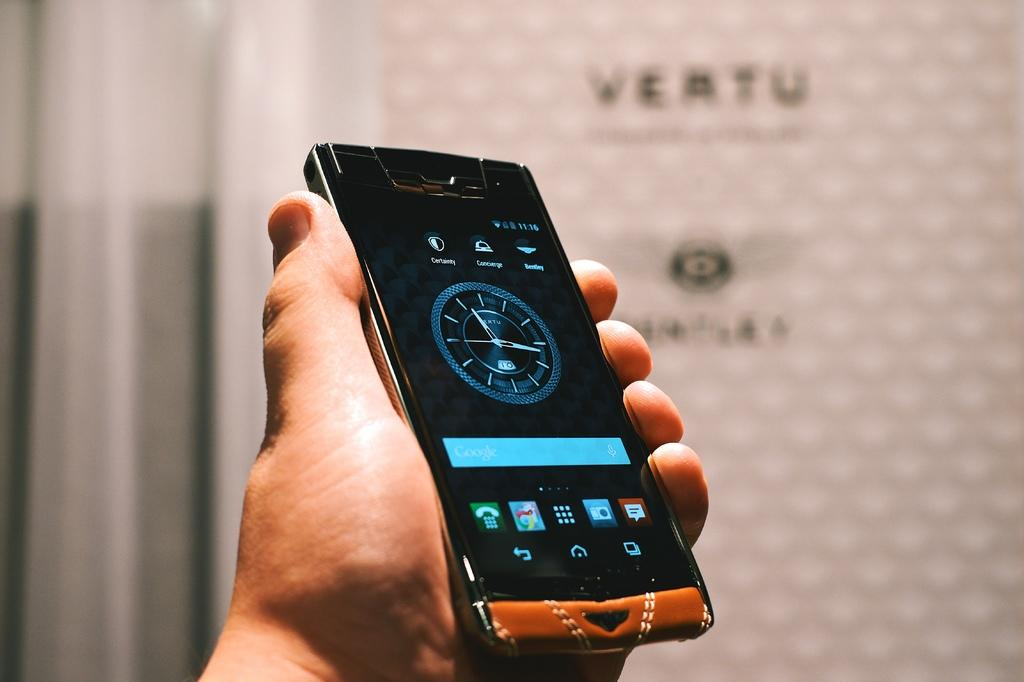<image>
Relay a brief, clear account of the picture shown. Vertu watch displayed on a phone in someone's hand 